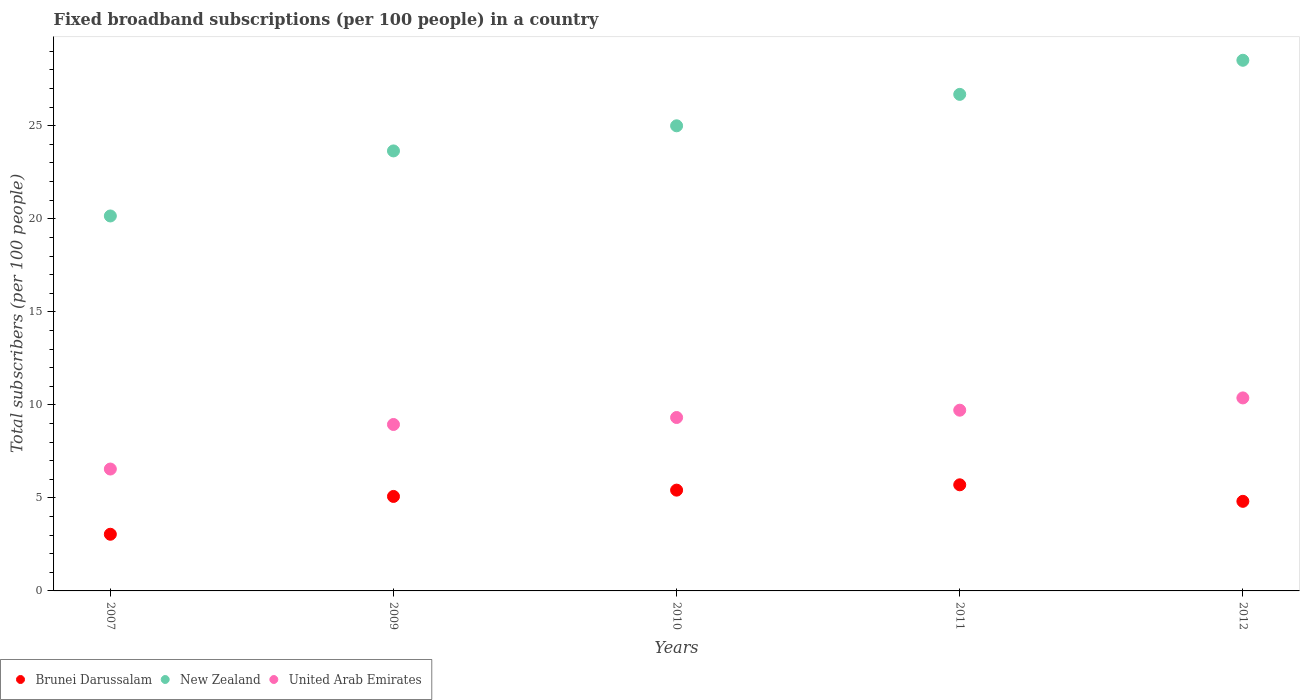How many different coloured dotlines are there?
Ensure brevity in your answer.  3. What is the number of broadband subscriptions in United Arab Emirates in 2007?
Provide a succinct answer. 6.55. Across all years, what is the maximum number of broadband subscriptions in United Arab Emirates?
Keep it short and to the point. 10.37. Across all years, what is the minimum number of broadband subscriptions in New Zealand?
Ensure brevity in your answer.  20.15. In which year was the number of broadband subscriptions in Brunei Darussalam maximum?
Give a very brief answer. 2011. In which year was the number of broadband subscriptions in United Arab Emirates minimum?
Give a very brief answer. 2007. What is the total number of broadband subscriptions in Brunei Darussalam in the graph?
Offer a terse response. 24.06. What is the difference between the number of broadband subscriptions in Brunei Darussalam in 2010 and that in 2012?
Provide a short and direct response. 0.6. What is the difference between the number of broadband subscriptions in Brunei Darussalam in 2010 and the number of broadband subscriptions in United Arab Emirates in 2012?
Provide a succinct answer. -4.96. What is the average number of broadband subscriptions in New Zealand per year?
Make the answer very short. 24.8. In the year 2009, what is the difference between the number of broadband subscriptions in Brunei Darussalam and number of broadband subscriptions in New Zealand?
Offer a terse response. -18.57. What is the ratio of the number of broadband subscriptions in Brunei Darussalam in 2011 to that in 2012?
Offer a terse response. 1.18. What is the difference between the highest and the second highest number of broadband subscriptions in United Arab Emirates?
Give a very brief answer. 0.66. What is the difference between the highest and the lowest number of broadband subscriptions in Brunei Darussalam?
Provide a succinct answer. 2.66. In how many years, is the number of broadband subscriptions in United Arab Emirates greater than the average number of broadband subscriptions in United Arab Emirates taken over all years?
Your answer should be very brief. 3. Does the number of broadband subscriptions in Brunei Darussalam monotonically increase over the years?
Make the answer very short. No. Is the number of broadband subscriptions in United Arab Emirates strictly greater than the number of broadband subscriptions in Brunei Darussalam over the years?
Your response must be concise. Yes. Is the number of broadband subscriptions in United Arab Emirates strictly less than the number of broadband subscriptions in Brunei Darussalam over the years?
Your answer should be very brief. No. How many dotlines are there?
Ensure brevity in your answer.  3. Are the values on the major ticks of Y-axis written in scientific E-notation?
Ensure brevity in your answer.  No. Does the graph contain grids?
Make the answer very short. No. Where does the legend appear in the graph?
Your answer should be compact. Bottom left. How many legend labels are there?
Ensure brevity in your answer.  3. What is the title of the graph?
Your response must be concise. Fixed broadband subscriptions (per 100 people) in a country. What is the label or title of the X-axis?
Provide a succinct answer. Years. What is the label or title of the Y-axis?
Provide a succinct answer. Total subscribers (per 100 people). What is the Total subscribers (per 100 people) in Brunei Darussalam in 2007?
Keep it short and to the point. 3.05. What is the Total subscribers (per 100 people) of New Zealand in 2007?
Offer a very short reply. 20.15. What is the Total subscribers (per 100 people) in United Arab Emirates in 2007?
Your answer should be compact. 6.55. What is the Total subscribers (per 100 people) of Brunei Darussalam in 2009?
Offer a very short reply. 5.08. What is the Total subscribers (per 100 people) of New Zealand in 2009?
Your answer should be compact. 23.65. What is the Total subscribers (per 100 people) in United Arab Emirates in 2009?
Your response must be concise. 8.95. What is the Total subscribers (per 100 people) of Brunei Darussalam in 2010?
Provide a succinct answer. 5.42. What is the Total subscribers (per 100 people) of New Zealand in 2010?
Ensure brevity in your answer.  25. What is the Total subscribers (per 100 people) of United Arab Emirates in 2010?
Make the answer very short. 9.32. What is the Total subscribers (per 100 people) in Brunei Darussalam in 2011?
Make the answer very short. 5.7. What is the Total subscribers (per 100 people) of New Zealand in 2011?
Keep it short and to the point. 26.69. What is the Total subscribers (per 100 people) in United Arab Emirates in 2011?
Offer a terse response. 9.71. What is the Total subscribers (per 100 people) of Brunei Darussalam in 2012?
Keep it short and to the point. 4.81. What is the Total subscribers (per 100 people) of New Zealand in 2012?
Ensure brevity in your answer.  28.52. What is the Total subscribers (per 100 people) in United Arab Emirates in 2012?
Offer a terse response. 10.37. Across all years, what is the maximum Total subscribers (per 100 people) of Brunei Darussalam?
Your response must be concise. 5.7. Across all years, what is the maximum Total subscribers (per 100 people) of New Zealand?
Offer a very short reply. 28.52. Across all years, what is the maximum Total subscribers (per 100 people) of United Arab Emirates?
Give a very brief answer. 10.37. Across all years, what is the minimum Total subscribers (per 100 people) in Brunei Darussalam?
Ensure brevity in your answer.  3.05. Across all years, what is the minimum Total subscribers (per 100 people) of New Zealand?
Keep it short and to the point. 20.15. Across all years, what is the minimum Total subscribers (per 100 people) in United Arab Emirates?
Offer a very short reply. 6.55. What is the total Total subscribers (per 100 people) in Brunei Darussalam in the graph?
Make the answer very short. 24.06. What is the total Total subscribers (per 100 people) of New Zealand in the graph?
Your answer should be compact. 124.01. What is the total Total subscribers (per 100 people) in United Arab Emirates in the graph?
Provide a short and direct response. 44.91. What is the difference between the Total subscribers (per 100 people) of Brunei Darussalam in 2007 and that in 2009?
Make the answer very short. -2.03. What is the difference between the Total subscribers (per 100 people) of New Zealand in 2007 and that in 2009?
Ensure brevity in your answer.  -3.5. What is the difference between the Total subscribers (per 100 people) of United Arab Emirates in 2007 and that in 2009?
Your response must be concise. -2.39. What is the difference between the Total subscribers (per 100 people) in Brunei Darussalam in 2007 and that in 2010?
Ensure brevity in your answer.  -2.37. What is the difference between the Total subscribers (per 100 people) in New Zealand in 2007 and that in 2010?
Make the answer very short. -4.85. What is the difference between the Total subscribers (per 100 people) of United Arab Emirates in 2007 and that in 2010?
Your response must be concise. -2.77. What is the difference between the Total subscribers (per 100 people) in Brunei Darussalam in 2007 and that in 2011?
Provide a short and direct response. -2.66. What is the difference between the Total subscribers (per 100 people) of New Zealand in 2007 and that in 2011?
Make the answer very short. -6.54. What is the difference between the Total subscribers (per 100 people) of United Arab Emirates in 2007 and that in 2011?
Offer a very short reply. -3.16. What is the difference between the Total subscribers (per 100 people) of Brunei Darussalam in 2007 and that in 2012?
Your answer should be compact. -1.77. What is the difference between the Total subscribers (per 100 people) of New Zealand in 2007 and that in 2012?
Offer a very short reply. -8.37. What is the difference between the Total subscribers (per 100 people) of United Arab Emirates in 2007 and that in 2012?
Your answer should be very brief. -3.82. What is the difference between the Total subscribers (per 100 people) in Brunei Darussalam in 2009 and that in 2010?
Make the answer very short. -0.34. What is the difference between the Total subscribers (per 100 people) of New Zealand in 2009 and that in 2010?
Provide a succinct answer. -1.35. What is the difference between the Total subscribers (per 100 people) in United Arab Emirates in 2009 and that in 2010?
Ensure brevity in your answer.  -0.38. What is the difference between the Total subscribers (per 100 people) in Brunei Darussalam in 2009 and that in 2011?
Your response must be concise. -0.63. What is the difference between the Total subscribers (per 100 people) of New Zealand in 2009 and that in 2011?
Your answer should be very brief. -3.04. What is the difference between the Total subscribers (per 100 people) in United Arab Emirates in 2009 and that in 2011?
Your answer should be very brief. -0.77. What is the difference between the Total subscribers (per 100 people) of Brunei Darussalam in 2009 and that in 2012?
Provide a succinct answer. 0.26. What is the difference between the Total subscribers (per 100 people) in New Zealand in 2009 and that in 2012?
Provide a succinct answer. -4.87. What is the difference between the Total subscribers (per 100 people) in United Arab Emirates in 2009 and that in 2012?
Ensure brevity in your answer.  -1.43. What is the difference between the Total subscribers (per 100 people) of Brunei Darussalam in 2010 and that in 2011?
Offer a very short reply. -0.29. What is the difference between the Total subscribers (per 100 people) of New Zealand in 2010 and that in 2011?
Ensure brevity in your answer.  -1.69. What is the difference between the Total subscribers (per 100 people) in United Arab Emirates in 2010 and that in 2011?
Give a very brief answer. -0.39. What is the difference between the Total subscribers (per 100 people) in Brunei Darussalam in 2010 and that in 2012?
Provide a short and direct response. 0.6. What is the difference between the Total subscribers (per 100 people) in New Zealand in 2010 and that in 2012?
Ensure brevity in your answer.  -3.52. What is the difference between the Total subscribers (per 100 people) in United Arab Emirates in 2010 and that in 2012?
Make the answer very short. -1.05. What is the difference between the Total subscribers (per 100 people) of Brunei Darussalam in 2011 and that in 2012?
Your answer should be very brief. 0.89. What is the difference between the Total subscribers (per 100 people) in New Zealand in 2011 and that in 2012?
Provide a short and direct response. -1.83. What is the difference between the Total subscribers (per 100 people) in United Arab Emirates in 2011 and that in 2012?
Offer a very short reply. -0.66. What is the difference between the Total subscribers (per 100 people) of Brunei Darussalam in 2007 and the Total subscribers (per 100 people) of New Zealand in 2009?
Your answer should be very brief. -20.6. What is the difference between the Total subscribers (per 100 people) of Brunei Darussalam in 2007 and the Total subscribers (per 100 people) of United Arab Emirates in 2009?
Your answer should be very brief. -5.9. What is the difference between the Total subscribers (per 100 people) in New Zealand in 2007 and the Total subscribers (per 100 people) in United Arab Emirates in 2009?
Your answer should be very brief. 11.21. What is the difference between the Total subscribers (per 100 people) in Brunei Darussalam in 2007 and the Total subscribers (per 100 people) in New Zealand in 2010?
Keep it short and to the point. -21.95. What is the difference between the Total subscribers (per 100 people) of Brunei Darussalam in 2007 and the Total subscribers (per 100 people) of United Arab Emirates in 2010?
Make the answer very short. -6.28. What is the difference between the Total subscribers (per 100 people) in New Zealand in 2007 and the Total subscribers (per 100 people) in United Arab Emirates in 2010?
Give a very brief answer. 10.83. What is the difference between the Total subscribers (per 100 people) of Brunei Darussalam in 2007 and the Total subscribers (per 100 people) of New Zealand in 2011?
Ensure brevity in your answer.  -23.64. What is the difference between the Total subscribers (per 100 people) of Brunei Darussalam in 2007 and the Total subscribers (per 100 people) of United Arab Emirates in 2011?
Keep it short and to the point. -6.67. What is the difference between the Total subscribers (per 100 people) in New Zealand in 2007 and the Total subscribers (per 100 people) in United Arab Emirates in 2011?
Keep it short and to the point. 10.44. What is the difference between the Total subscribers (per 100 people) in Brunei Darussalam in 2007 and the Total subscribers (per 100 people) in New Zealand in 2012?
Provide a succinct answer. -25.48. What is the difference between the Total subscribers (per 100 people) in Brunei Darussalam in 2007 and the Total subscribers (per 100 people) in United Arab Emirates in 2012?
Provide a short and direct response. -7.33. What is the difference between the Total subscribers (per 100 people) of New Zealand in 2007 and the Total subscribers (per 100 people) of United Arab Emirates in 2012?
Provide a succinct answer. 9.78. What is the difference between the Total subscribers (per 100 people) in Brunei Darussalam in 2009 and the Total subscribers (per 100 people) in New Zealand in 2010?
Provide a succinct answer. -19.92. What is the difference between the Total subscribers (per 100 people) in Brunei Darussalam in 2009 and the Total subscribers (per 100 people) in United Arab Emirates in 2010?
Your answer should be very brief. -4.24. What is the difference between the Total subscribers (per 100 people) of New Zealand in 2009 and the Total subscribers (per 100 people) of United Arab Emirates in 2010?
Your answer should be compact. 14.33. What is the difference between the Total subscribers (per 100 people) in Brunei Darussalam in 2009 and the Total subscribers (per 100 people) in New Zealand in 2011?
Your answer should be very brief. -21.61. What is the difference between the Total subscribers (per 100 people) of Brunei Darussalam in 2009 and the Total subscribers (per 100 people) of United Arab Emirates in 2011?
Your response must be concise. -4.64. What is the difference between the Total subscribers (per 100 people) of New Zealand in 2009 and the Total subscribers (per 100 people) of United Arab Emirates in 2011?
Offer a very short reply. 13.94. What is the difference between the Total subscribers (per 100 people) of Brunei Darussalam in 2009 and the Total subscribers (per 100 people) of New Zealand in 2012?
Offer a terse response. -23.44. What is the difference between the Total subscribers (per 100 people) in Brunei Darussalam in 2009 and the Total subscribers (per 100 people) in United Arab Emirates in 2012?
Your response must be concise. -5.3. What is the difference between the Total subscribers (per 100 people) of New Zealand in 2009 and the Total subscribers (per 100 people) of United Arab Emirates in 2012?
Make the answer very short. 13.28. What is the difference between the Total subscribers (per 100 people) in Brunei Darussalam in 2010 and the Total subscribers (per 100 people) in New Zealand in 2011?
Offer a very short reply. -21.27. What is the difference between the Total subscribers (per 100 people) of Brunei Darussalam in 2010 and the Total subscribers (per 100 people) of United Arab Emirates in 2011?
Offer a terse response. -4.3. What is the difference between the Total subscribers (per 100 people) in New Zealand in 2010 and the Total subscribers (per 100 people) in United Arab Emirates in 2011?
Give a very brief answer. 15.29. What is the difference between the Total subscribers (per 100 people) of Brunei Darussalam in 2010 and the Total subscribers (per 100 people) of New Zealand in 2012?
Make the answer very short. -23.1. What is the difference between the Total subscribers (per 100 people) of Brunei Darussalam in 2010 and the Total subscribers (per 100 people) of United Arab Emirates in 2012?
Provide a succinct answer. -4.96. What is the difference between the Total subscribers (per 100 people) of New Zealand in 2010 and the Total subscribers (per 100 people) of United Arab Emirates in 2012?
Your response must be concise. 14.63. What is the difference between the Total subscribers (per 100 people) of Brunei Darussalam in 2011 and the Total subscribers (per 100 people) of New Zealand in 2012?
Your answer should be very brief. -22.82. What is the difference between the Total subscribers (per 100 people) of Brunei Darussalam in 2011 and the Total subscribers (per 100 people) of United Arab Emirates in 2012?
Ensure brevity in your answer.  -4.67. What is the difference between the Total subscribers (per 100 people) in New Zealand in 2011 and the Total subscribers (per 100 people) in United Arab Emirates in 2012?
Ensure brevity in your answer.  16.31. What is the average Total subscribers (per 100 people) of Brunei Darussalam per year?
Make the answer very short. 4.81. What is the average Total subscribers (per 100 people) in New Zealand per year?
Your answer should be compact. 24.8. What is the average Total subscribers (per 100 people) of United Arab Emirates per year?
Provide a succinct answer. 8.98. In the year 2007, what is the difference between the Total subscribers (per 100 people) in Brunei Darussalam and Total subscribers (per 100 people) in New Zealand?
Your response must be concise. -17.11. In the year 2007, what is the difference between the Total subscribers (per 100 people) in Brunei Darussalam and Total subscribers (per 100 people) in United Arab Emirates?
Your answer should be compact. -3.51. In the year 2007, what is the difference between the Total subscribers (per 100 people) in New Zealand and Total subscribers (per 100 people) in United Arab Emirates?
Your response must be concise. 13.6. In the year 2009, what is the difference between the Total subscribers (per 100 people) of Brunei Darussalam and Total subscribers (per 100 people) of New Zealand?
Provide a succinct answer. -18.57. In the year 2009, what is the difference between the Total subscribers (per 100 people) of Brunei Darussalam and Total subscribers (per 100 people) of United Arab Emirates?
Provide a short and direct response. -3.87. In the year 2009, what is the difference between the Total subscribers (per 100 people) of New Zealand and Total subscribers (per 100 people) of United Arab Emirates?
Offer a terse response. 14.7. In the year 2010, what is the difference between the Total subscribers (per 100 people) of Brunei Darussalam and Total subscribers (per 100 people) of New Zealand?
Your response must be concise. -19.58. In the year 2010, what is the difference between the Total subscribers (per 100 people) of Brunei Darussalam and Total subscribers (per 100 people) of United Arab Emirates?
Your answer should be compact. -3.9. In the year 2010, what is the difference between the Total subscribers (per 100 people) of New Zealand and Total subscribers (per 100 people) of United Arab Emirates?
Your answer should be very brief. 15.68. In the year 2011, what is the difference between the Total subscribers (per 100 people) of Brunei Darussalam and Total subscribers (per 100 people) of New Zealand?
Make the answer very short. -20.98. In the year 2011, what is the difference between the Total subscribers (per 100 people) of Brunei Darussalam and Total subscribers (per 100 people) of United Arab Emirates?
Keep it short and to the point. -4.01. In the year 2011, what is the difference between the Total subscribers (per 100 people) of New Zealand and Total subscribers (per 100 people) of United Arab Emirates?
Offer a very short reply. 16.97. In the year 2012, what is the difference between the Total subscribers (per 100 people) in Brunei Darussalam and Total subscribers (per 100 people) in New Zealand?
Ensure brevity in your answer.  -23.71. In the year 2012, what is the difference between the Total subscribers (per 100 people) of Brunei Darussalam and Total subscribers (per 100 people) of United Arab Emirates?
Keep it short and to the point. -5.56. In the year 2012, what is the difference between the Total subscribers (per 100 people) in New Zealand and Total subscribers (per 100 people) in United Arab Emirates?
Your answer should be very brief. 18.15. What is the ratio of the Total subscribers (per 100 people) in Brunei Darussalam in 2007 to that in 2009?
Keep it short and to the point. 0.6. What is the ratio of the Total subscribers (per 100 people) in New Zealand in 2007 to that in 2009?
Offer a very short reply. 0.85. What is the ratio of the Total subscribers (per 100 people) of United Arab Emirates in 2007 to that in 2009?
Offer a terse response. 0.73. What is the ratio of the Total subscribers (per 100 people) of Brunei Darussalam in 2007 to that in 2010?
Your response must be concise. 0.56. What is the ratio of the Total subscribers (per 100 people) of New Zealand in 2007 to that in 2010?
Provide a succinct answer. 0.81. What is the ratio of the Total subscribers (per 100 people) in United Arab Emirates in 2007 to that in 2010?
Offer a terse response. 0.7. What is the ratio of the Total subscribers (per 100 people) in Brunei Darussalam in 2007 to that in 2011?
Your answer should be very brief. 0.53. What is the ratio of the Total subscribers (per 100 people) in New Zealand in 2007 to that in 2011?
Your answer should be very brief. 0.76. What is the ratio of the Total subscribers (per 100 people) of United Arab Emirates in 2007 to that in 2011?
Ensure brevity in your answer.  0.67. What is the ratio of the Total subscribers (per 100 people) in Brunei Darussalam in 2007 to that in 2012?
Provide a succinct answer. 0.63. What is the ratio of the Total subscribers (per 100 people) in New Zealand in 2007 to that in 2012?
Give a very brief answer. 0.71. What is the ratio of the Total subscribers (per 100 people) in United Arab Emirates in 2007 to that in 2012?
Give a very brief answer. 0.63. What is the ratio of the Total subscribers (per 100 people) of New Zealand in 2009 to that in 2010?
Give a very brief answer. 0.95. What is the ratio of the Total subscribers (per 100 people) in United Arab Emirates in 2009 to that in 2010?
Offer a terse response. 0.96. What is the ratio of the Total subscribers (per 100 people) of Brunei Darussalam in 2009 to that in 2011?
Keep it short and to the point. 0.89. What is the ratio of the Total subscribers (per 100 people) of New Zealand in 2009 to that in 2011?
Your answer should be compact. 0.89. What is the ratio of the Total subscribers (per 100 people) of United Arab Emirates in 2009 to that in 2011?
Keep it short and to the point. 0.92. What is the ratio of the Total subscribers (per 100 people) of Brunei Darussalam in 2009 to that in 2012?
Offer a very short reply. 1.05. What is the ratio of the Total subscribers (per 100 people) of New Zealand in 2009 to that in 2012?
Provide a short and direct response. 0.83. What is the ratio of the Total subscribers (per 100 people) in United Arab Emirates in 2009 to that in 2012?
Give a very brief answer. 0.86. What is the ratio of the Total subscribers (per 100 people) in Brunei Darussalam in 2010 to that in 2011?
Keep it short and to the point. 0.95. What is the ratio of the Total subscribers (per 100 people) in New Zealand in 2010 to that in 2011?
Your answer should be compact. 0.94. What is the ratio of the Total subscribers (per 100 people) in United Arab Emirates in 2010 to that in 2011?
Keep it short and to the point. 0.96. What is the ratio of the Total subscribers (per 100 people) in New Zealand in 2010 to that in 2012?
Keep it short and to the point. 0.88. What is the ratio of the Total subscribers (per 100 people) in United Arab Emirates in 2010 to that in 2012?
Your answer should be compact. 0.9. What is the ratio of the Total subscribers (per 100 people) in Brunei Darussalam in 2011 to that in 2012?
Your answer should be compact. 1.18. What is the ratio of the Total subscribers (per 100 people) of New Zealand in 2011 to that in 2012?
Keep it short and to the point. 0.94. What is the ratio of the Total subscribers (per 100 people) in United Arab Emirates in 2011 to that in 2012?
Provide a short and direct response. 0.94. What is the difference between the highest and the second highest Total subscribers (per 100 people) of Brunei Darussalam?
Keep it short and to the point. 0.29. What is the difference between the highest and the second highest Total subscribers (per 100 people) in New Zealand?
Keep it short and to the point. 1.83. What is the difference between the highest and the second highest Total subscribers (per 100 people) of United Arab Emirates?
Offer a very short reply. 0.66. What is the difference between the highest and the lowest Total subscribers (per 100 people) of Brunei Darussalam?
Provide a succinct answer. 2.66. What is the difference between the highest and the lowest Total subscribers (per 100 people) of New Zealand?
Keep it short and to the point. 8.37. What is the difference between the highest and the lowest Total subscribers (per 100 people) in United Arab Emirates?
Your response must be concise. 3.82. 